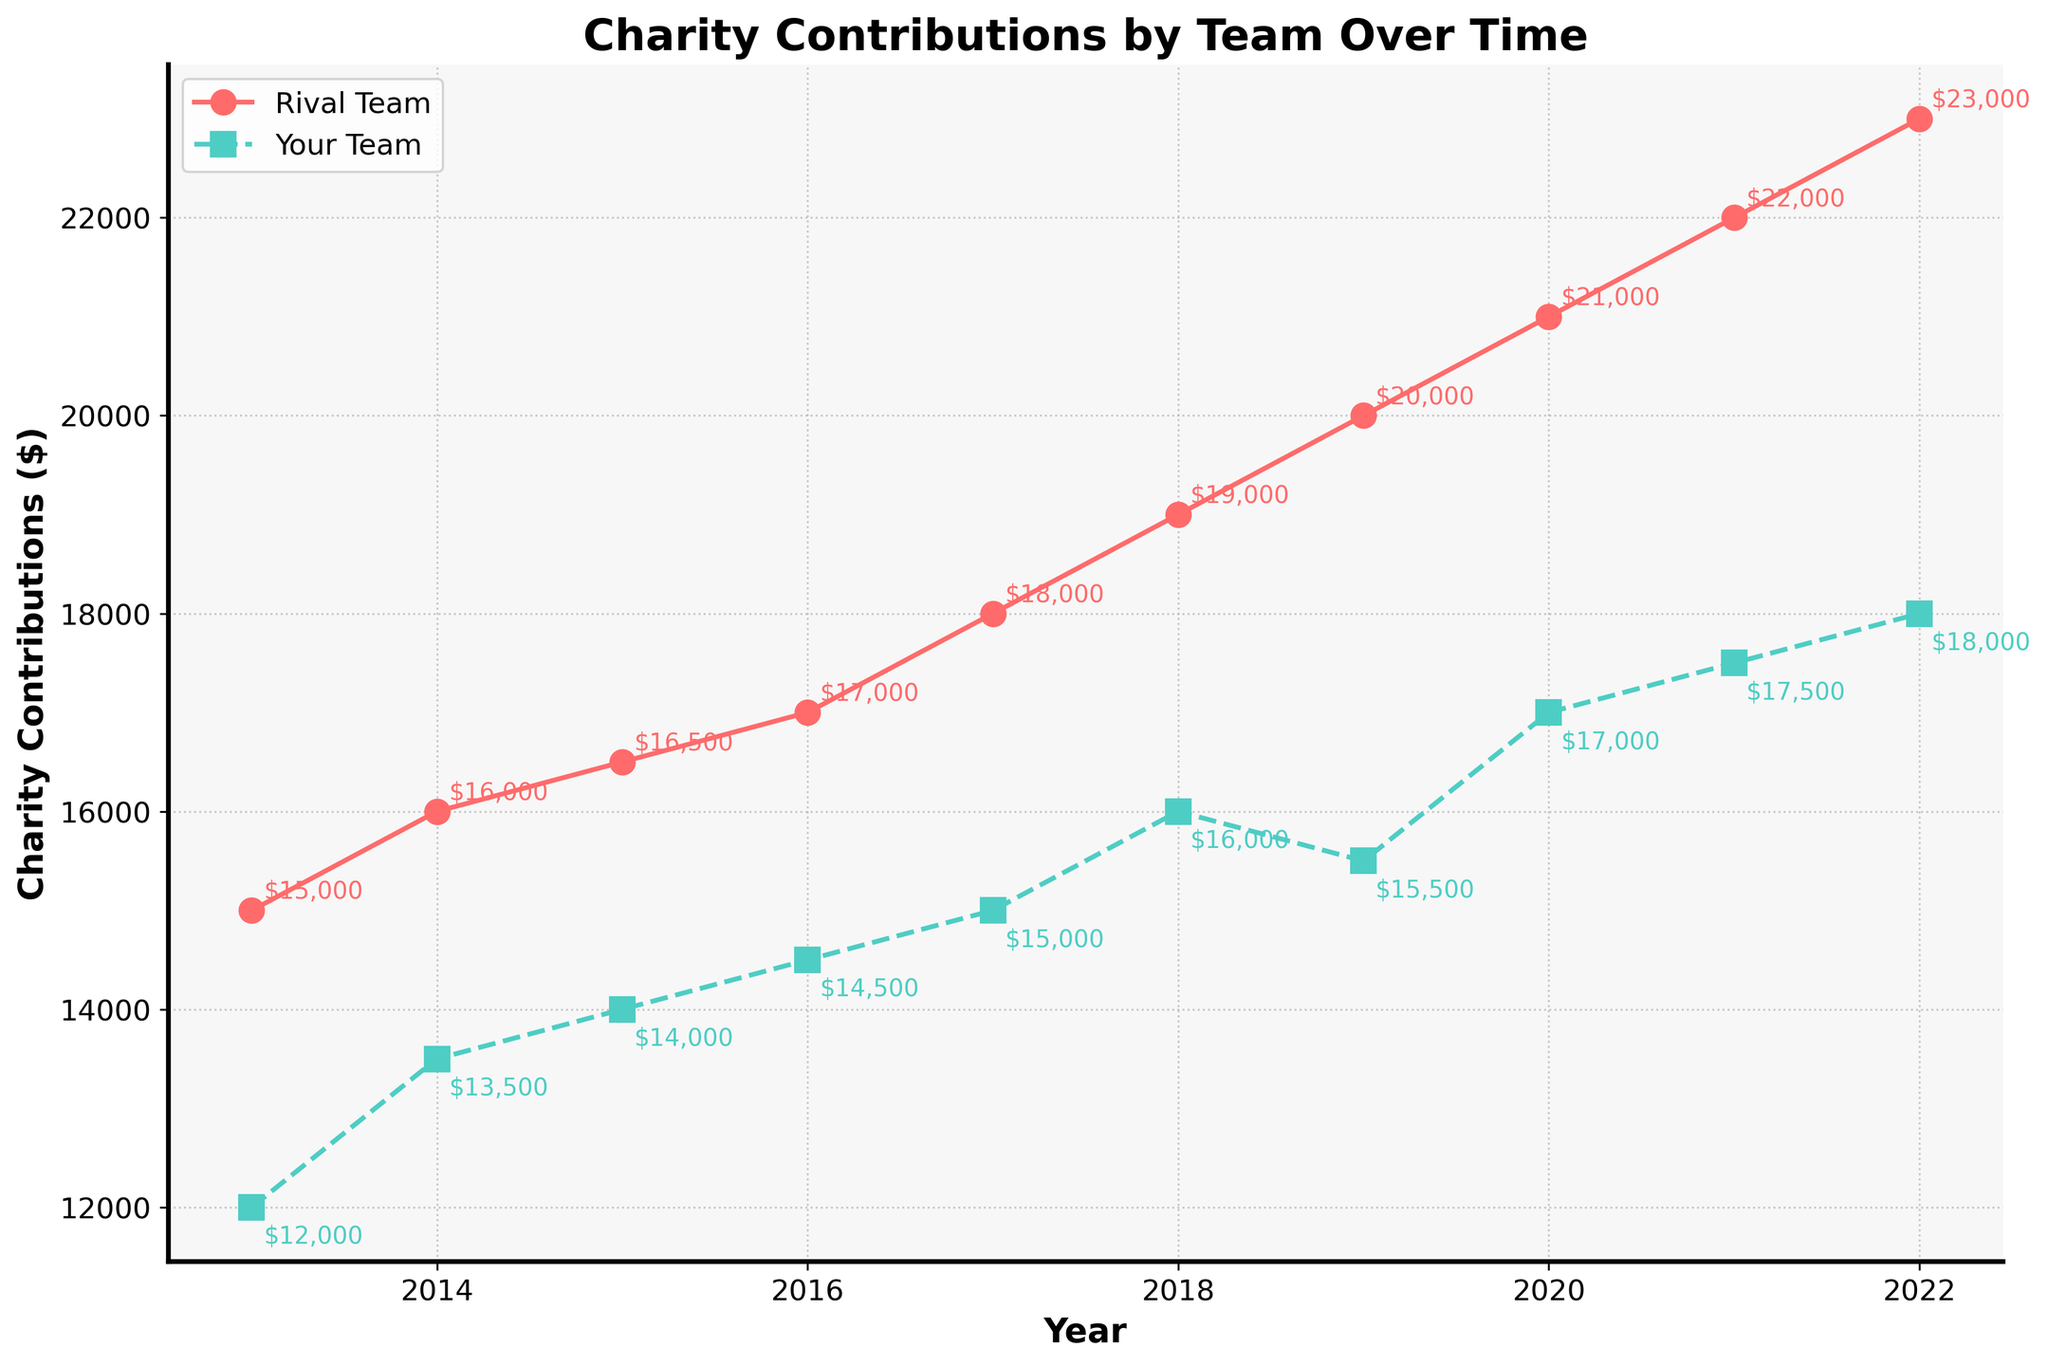what is the title of the figure? The title can be found at the top of the figure. It states "Charity Contributions by Team Over Time".
Answer: Charity Contributions by Team Over Time How many years are shown in the figure? Count the distinct ticks or x-axis markers labeled with years. The range covers from 2013 to 2022.
Answer: 10 Which team had higher charity contributions in 2021? Compare the data points for 2021 for both teams. Rival Team contributed $22,000 and Your Team contributed $17,500.
Answer: Rival Team What was the difference in charity contributions between the two teams in 2015? Note the contribution amounts for both teams in 2015. Subtract Your Team's $14,000 from Rival Team's $16,500.
Answer: $2,500 How much did Your Team's contributions increase from 2013 to 2014? Look at the contributions for Your Team in 2013 ($12,000) and 2014 ($13,500). Subtract the 2013 value from the 2014 value.
Answer: $1,500 Which year showed the highest contributions for Rival Team? Examine the data points for Rival Team. The highest value is observed in 2022 with $23,000.
Answer: 2022 In which year did both teams have the closest contribution amounts? Compare the difference in contributions each year. The smallest difference is in 2019, where Rival Team had $20,000 and Your Team had $15,500.
Answer: 2015 What is the upward trend pattern for Your Team's contributions? Observe the plot for all years. There is a general upward slope indicating increases almost each year, from $12,000 in 2013 to $18,000 in 2022.
Answer: Increasing How much total did the Rival Team contribute to charity from 2013 to 2022? Add up all the yearly contributions for the Rival Team from 2013 to 2022. [15000 + 16000 + 16500 + 17000 + 18000 + 19000 + 20000 + 21000 + 22000 + 23000]
Answer: $187,500 